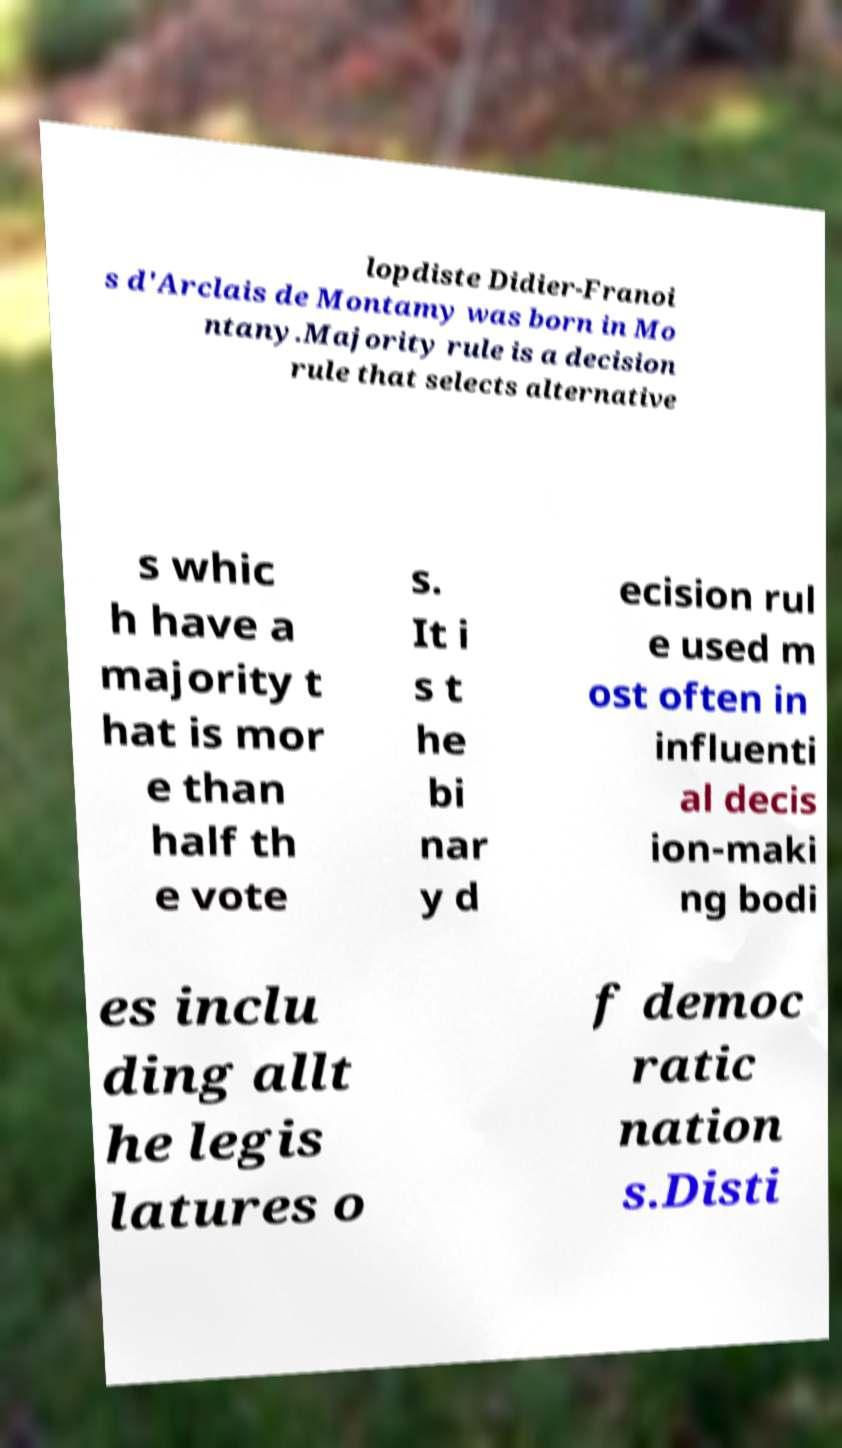Please read and relay the text visible in this image. What does it say? lopdiste Didier-Franoi s d'Arclais de Montamy was born in Mo ntany.Majority rule is a decision rule that selects alternative s whic h have a majority t hat is mor e than half th e vote s. It i s t he bi nar y d ecision rul e used m ost often in influenti al decis ion-maki ng bodi es inclu ding allt he legis latures o f democ ratic nation s.Disti 